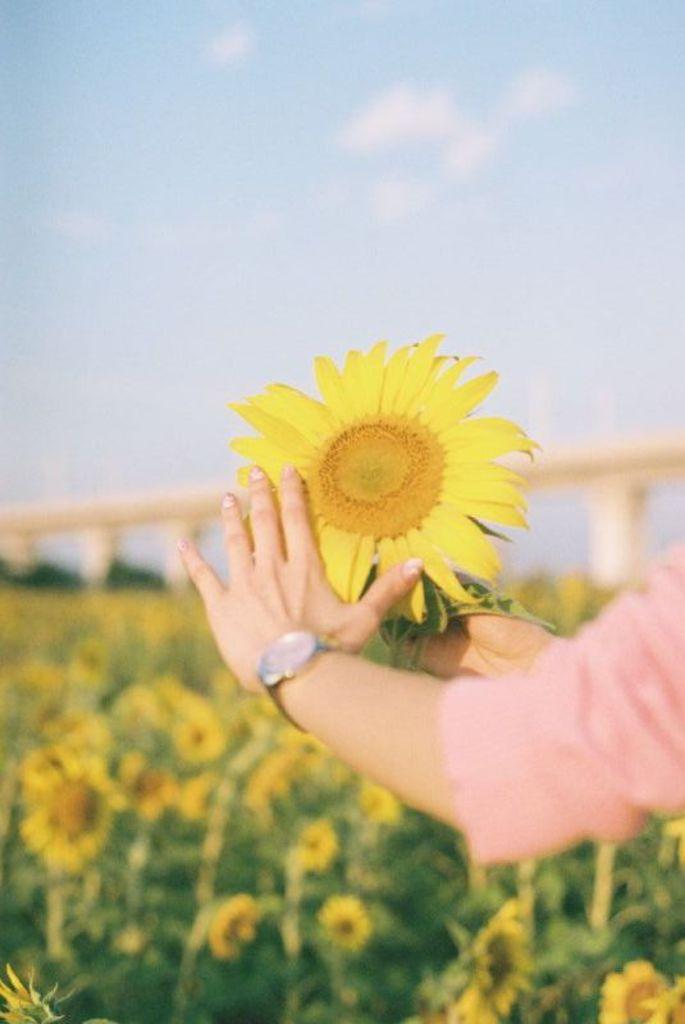What can be seen on the right side of the image? There is a person's hand holding a flower on the right side of the image. What is located in the middle of the image? There are flowers and a bridge in the middle of the image. What is visible at the top of the image? The sky is visible at the top of the image. How many socks are visible on the bridge in the image? There are no socks visible in the image; the focus is on the flowers and the bridge. What type of teeth can be seen in the image? There are no teeth visible in the image. 